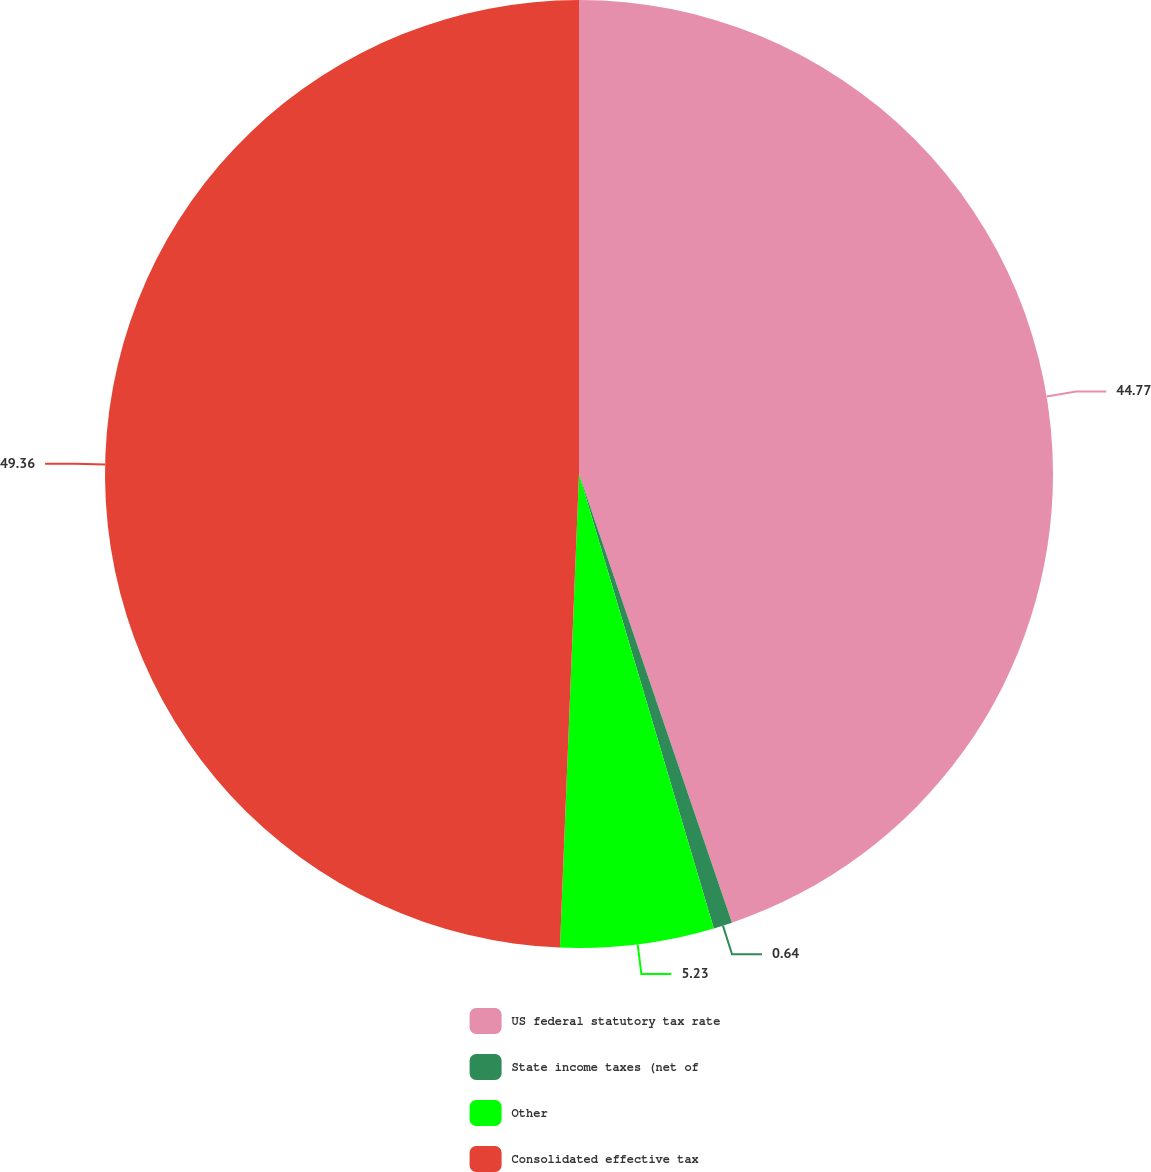Convert chart to OTSL. <chart><loc_0><loc_0><loc_500><loc_500><pie_chart><fcel>US federal statutory tax rate<fcel>State income taxes (net of<fcel>Other<fcel>Consolidated effective tax<nl><fcel>44.77%<fcel>0.64%<fcel>5.23%<fcel>49.36%<nl></chart> 